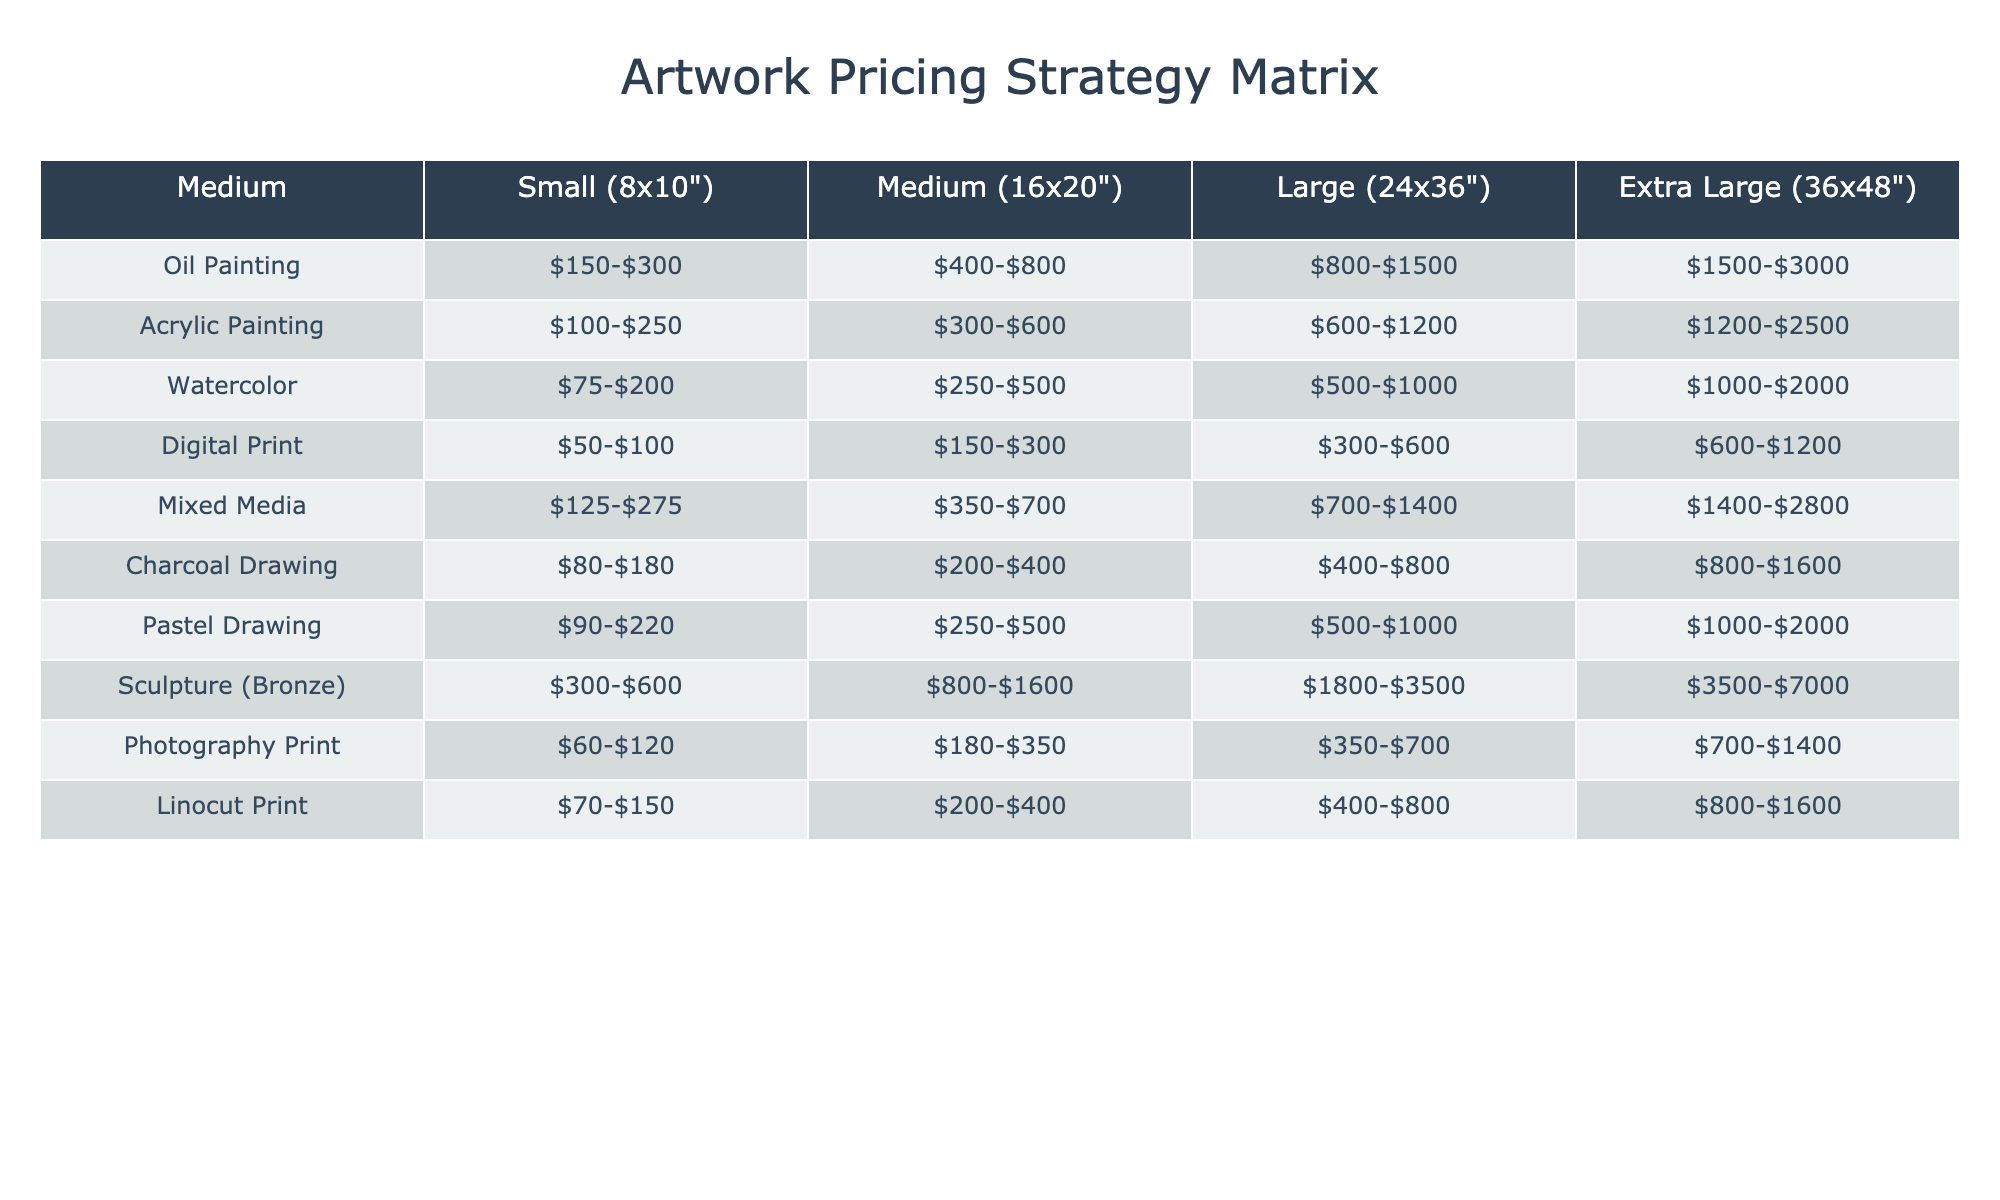What is the price range for a small Oil Painting? The table shows the price range for a small Oil Painting listed as $150 to $300.
Answer: $150-$300 Which medium has the highest price range for Extravagant size? By checking the last column for each medium, Sculpture (Bronze) has the highest range at $3500 to $7000.
Answer: Sculpture (Bronze) What is the difference in the price range between a Medium Acrylic Painting and a Medium Sculpture (Bronze)? The price range for Medium Acrylic Painting is $300 to $600, and for Medium Sculpture (Bronze) it is $800 to $1600. The difference is ($800 - $300) = $500.
Answer: $500 Is the price for a Medium Digital Print less than that for a Medium Watercolor painting? Comparing the Medium Digital Print ($150-$300) and Medium Watercolor ($250-$500), the lower end of Digital Print is less than the lower end of Watercolor, thus the statement is true.
Answer: Yes What are the average price ranges for Large artwork sizes across all mediums? To find the average, consider the following ranges: Oil Painting ($800-$1500), Acrylic ($600-$1200), Watercolor ($500-$1000), Digital Print ($300-$600), Mixed Media ($700-$1400), Charcoal Drawing ($400-$800), Pastel Drawing ($500-$1000), Sculpture (Bronze) ($1800-$3500), Photography Print ($350-$700), Linocut Print ($400-$800). The average can be calculated by finding the midpoint of each range and averaging those values, which gives a rough estimate of about $920.
Answer: Approximately $920 Which artwork medium offers the lowest price for Small size? By examining the first column, Watercolor's price range for Small size is $75 to $200, which is the lowest compared to others.
Answer: Watercolor If someone wants to buy a Large Charcoal Drawing and a Large Mixed Media piece, what is the total price range they could expect to pay? For a Large Charcoal Drawing, the price range is $400 to $800, and for Large Mixed Media, it is $700 to $1400. Adding these ranges gives a total price range of ($400 + $700) to ($800 + $1400), resulting in $1100 to $2200.
Answer: $1100-$2200 What medium has the highest starting price for Extra Large sizes? Checking the Extra Large price range, Sculpture (Bronze) starts at $3500, which is higher than all others.
Answer: Sculpture (Bronze) How much more expensive is an Extra Large Acrylic Painting than a Small Acrylic Painting at the upper end of their price ranges? The upper end for Extra Large Acrylic Painting is $2500 and for Small it's $250. The higher end difference is ($2500 - $250) = $2250.
Answer: $2250 If I want to display three different Small artworks, should I expect to spend more than $600? For Small artworks, the maximum price is $300 for an Oil Painting. Thus, the maximum combined price for three would be $300 * 3 = $900, which is greater than $600.
Answer: Yes 